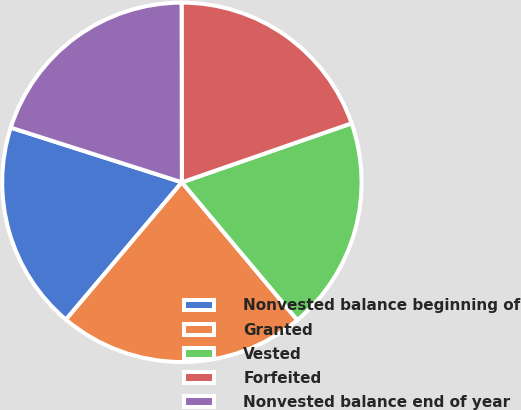Convert chart. <chart><loc_0><loc_0><loc_500><loc_500><pie_chart><fcel>Nonvested balance beginning of<fcel>Granted<fcel>Vested<fcel>Forfeited<fcel>Nonvested balance end of year<nl><fcel>18.76%<fcel>22.26%<fcel>19.22%<fcel>19.7%<fcel>20.05%<nl></chart> 